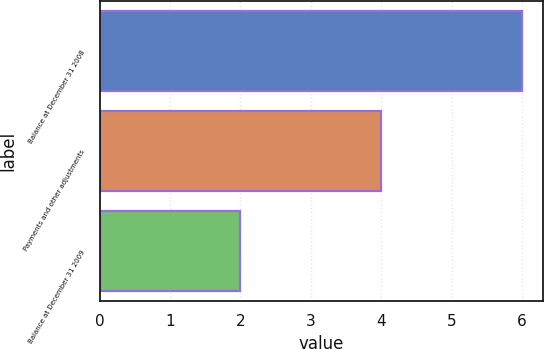Convert chart to OTSL. <chart><loc_0><loc_0><loc_500><loc_500><bar_chart><fcel>Balance at December 31 2008<fcel>Payments and other adjustments<fcel>Balance at December 31 2009<nl><fcel>6<fcel>4<fcel>2<nl></chart> 